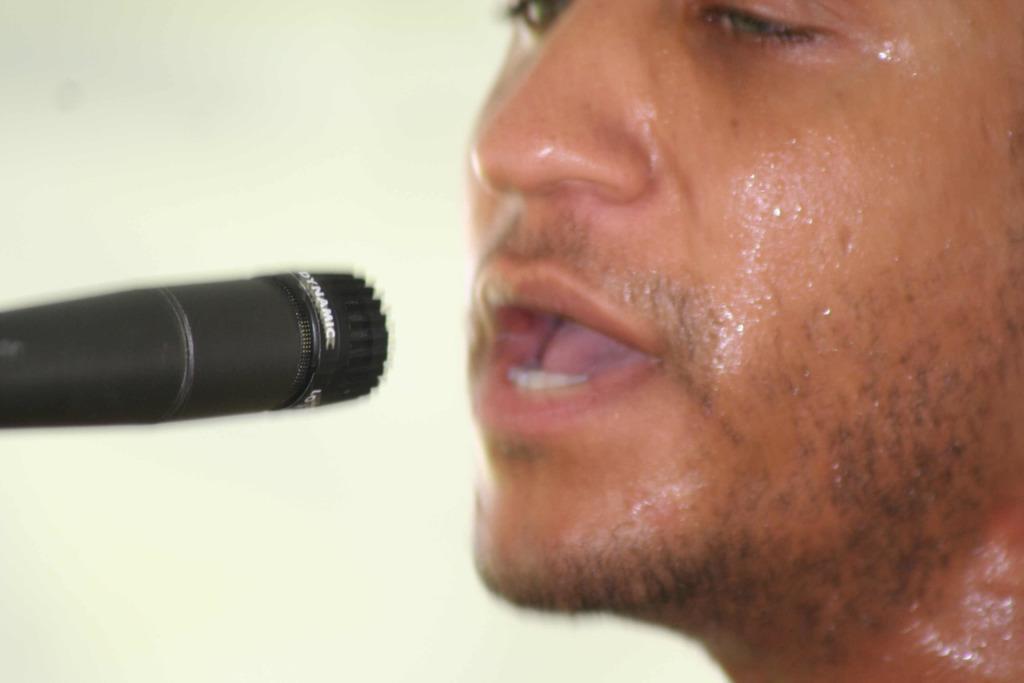In one or two sentences, can you explain what this image depicts? In this image there is a person singing in a mic. In the background of the image there is wall. 